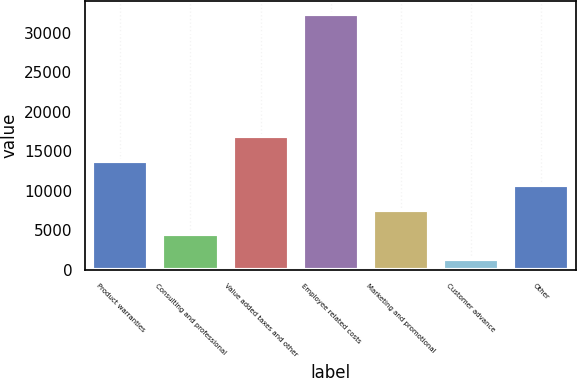Convert chart to OTSL. <chart><loc_0><loc_0><loc_500><loc_500><bar_chart><fcel>Product warranties<fcel>Consulting and professional<fcel>Value added taxes and other<fcel>Employee related costs<fcel>Marketing and promotional<fcel>Customer advance<fcel>Other<nl><fcel>13776.8<fcel>4462.7<fcel>16881.5<fcel>32405<fcel>7567.4<fcel>1358<fcel>10672.1<nl></chart> 